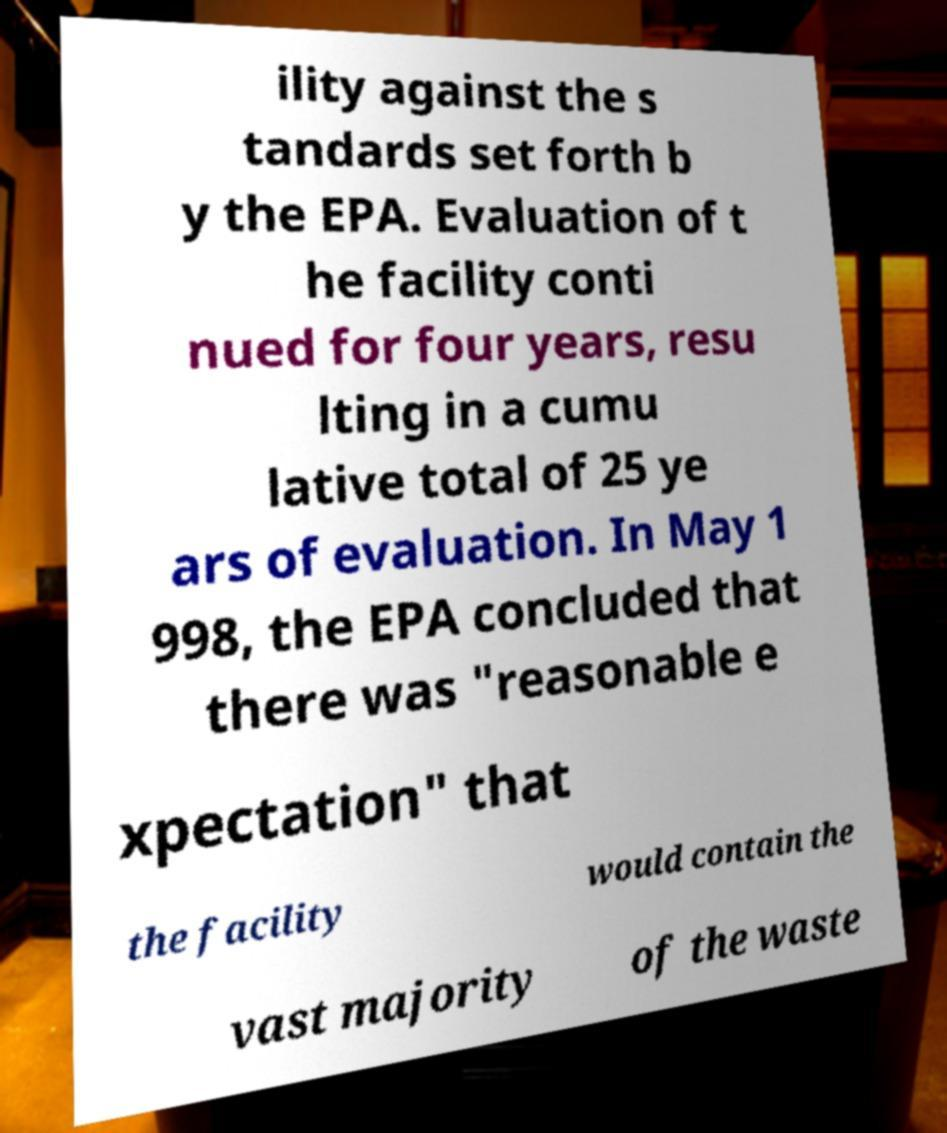Please identify and transcribe the text found in this image. ility against the s tandards set forth b y the EPA. Evaluation of t he facility conti nued for four years, resu lting in a cumu lative total of 25 ye ars of evaluation. In May 1 998, the EPA concluded that there was "reasonable e xpectation" that the facility would contain the vast majority of the waste 